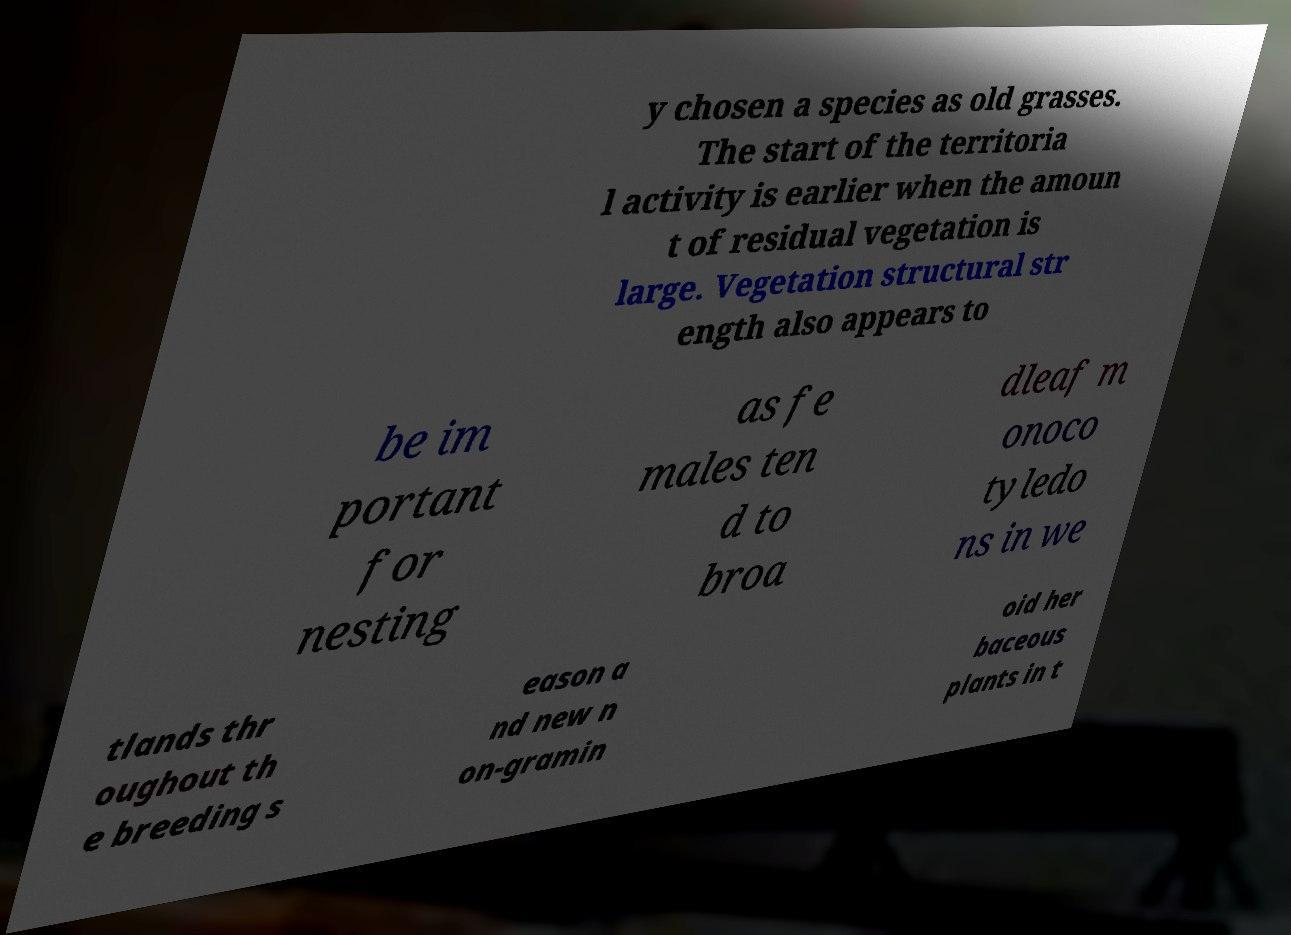What messages or text are displayed in this image? I need them in a readable, typed format. y chosen a species as old grasses. The start of the territoria l activity is earlier when the amoun t of residual vegetation is large. Vegetation structural str ength also appears to be im portant for nesting as fe males ten d to broa dleaf m onoco tyledo ns in we tlands thr oughout th e breeding s eason a nd new n on-gramin oid her baceous plants in t 